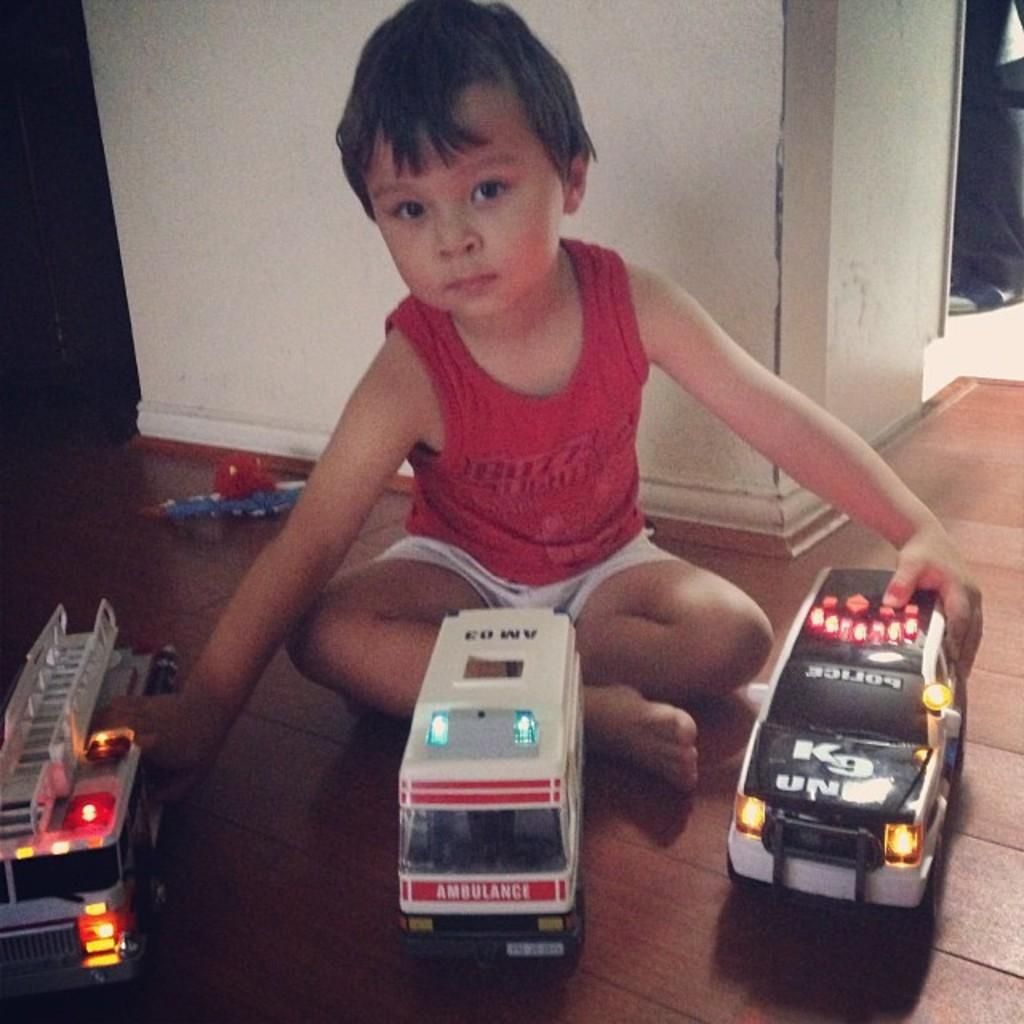Who is in the image? There is a boy in the image. What is the boy doing in the image? The boy is sitting on the floor and playing with toys. Where are the toys located in relation to the boy? The toys are in front of the boy. What can be seen in the background of the image? There is a wall in the background of the image. How many dimes can be seen on the boy's foot in the image? There are no dimes visible on the boy's foot in the image. What type of insurance does the boy have in the image? There is no information about insurance in the image. 